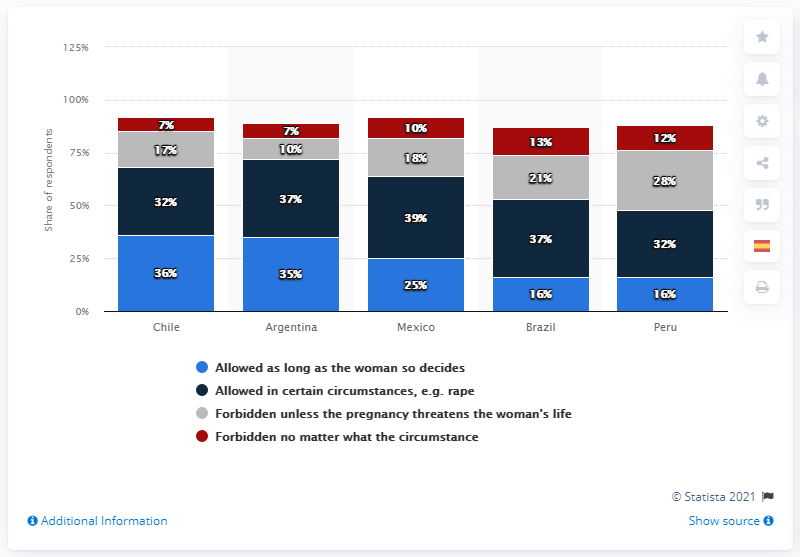List a handful of essential elements in this visual. According to the Peruvian respondents, 32% said that they only allow abortion in certain circumstances. According to the survey, 35% of respondents in Argentina agreed with abortion. According to the survey, 36% of Chilean respondents agreed that abortion should be completely prohibited in all circumstances. According to a recent survey, a significant percentage of Brazilians believe that abortion should be completely forbidden in all cases. Brazil had the highest percentage of respondents who believed that abortion should be forbidden in all cases, according to the data. 